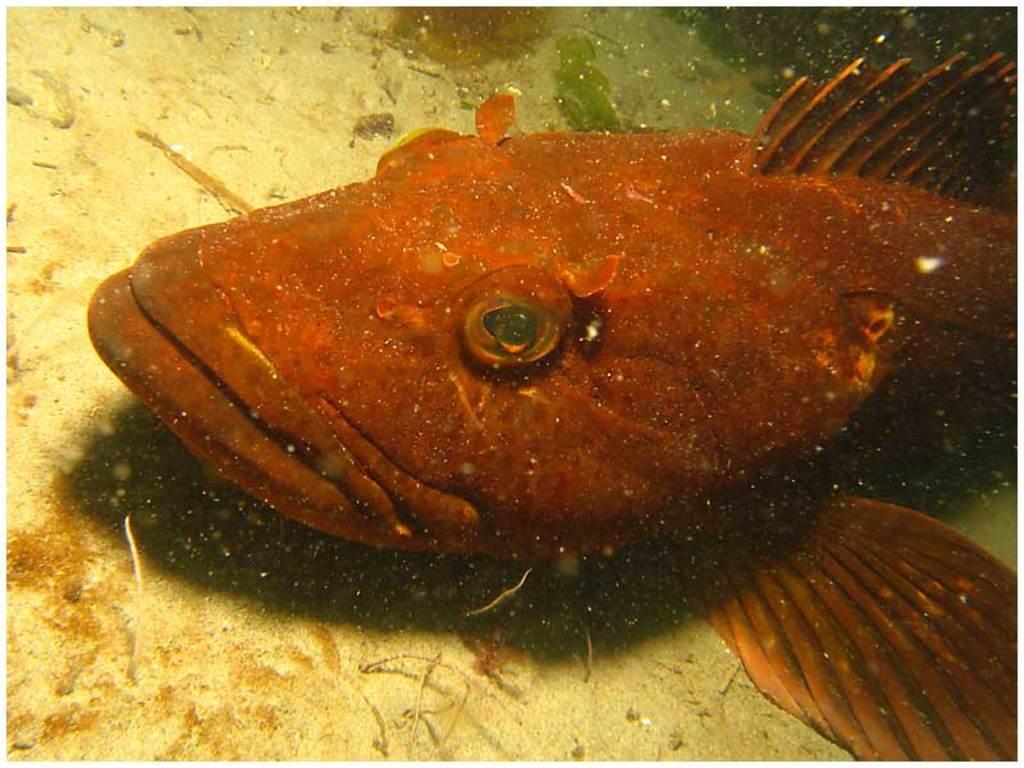Could you give a brief overview of what you see in this image? In the center of this picture we can see a fish which seems to be in the aquarium and we can see some other items. 